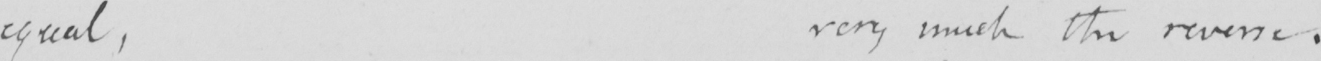Transcribe the text shown in this historical manuscript line. equal , very much the reverse . 